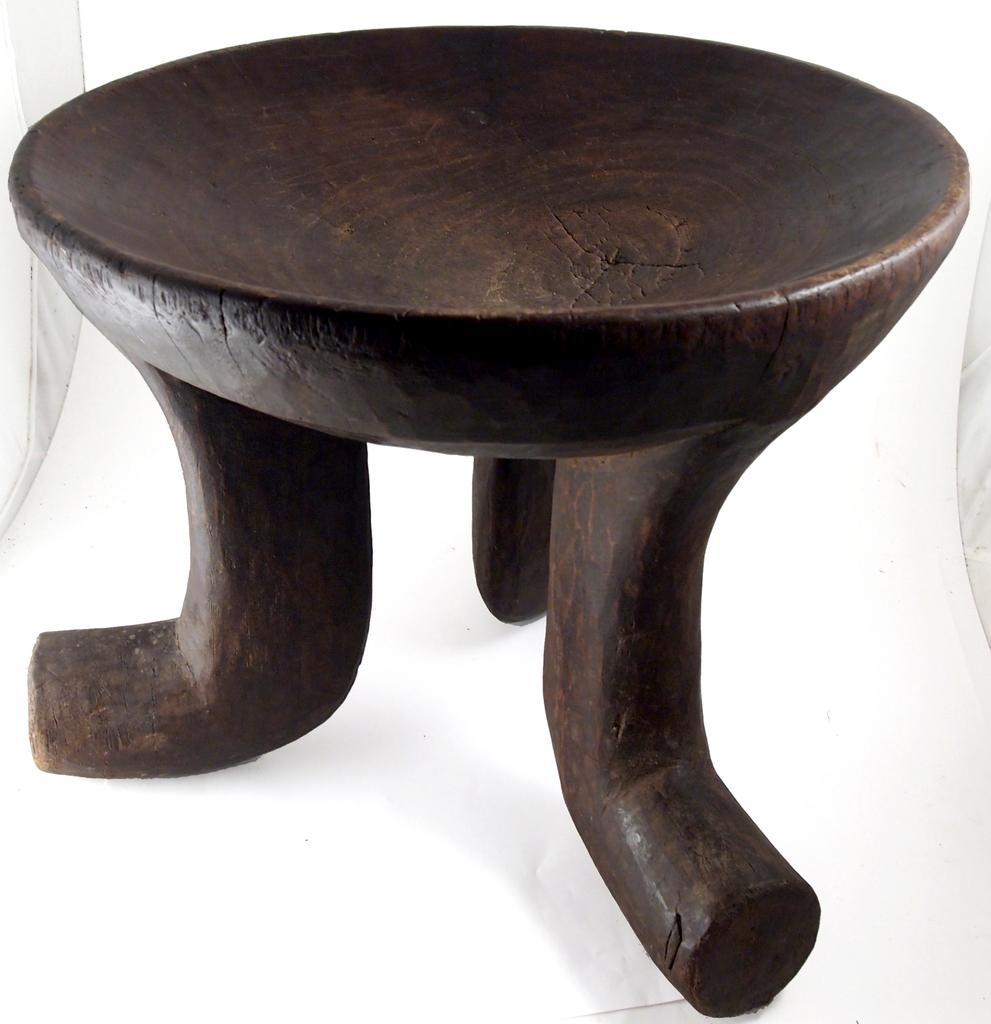How would you summarize this image in a sentence or two? In this image I see the brown color thing over here on this white color surface. 